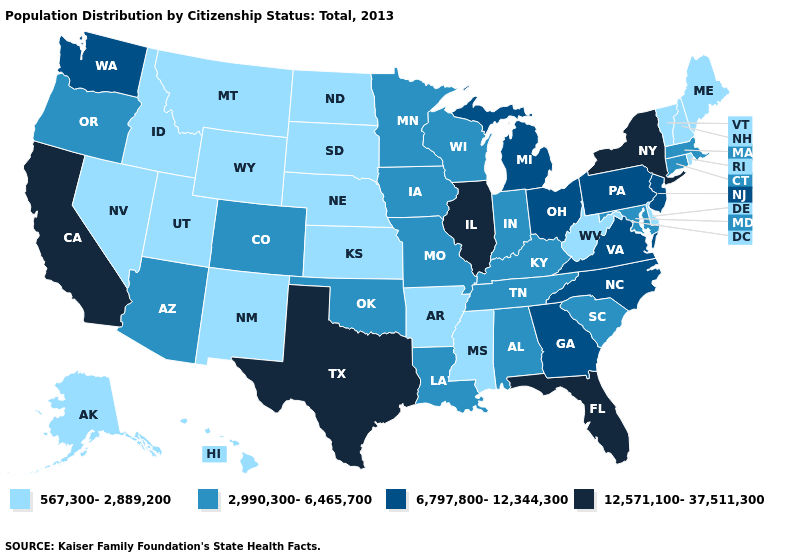Name the states that have a value in the range 2,990,300-6,465,700?
Write a very short answer. Alabama, Arizona, Colorado, Connecticut, Indiana, Iowa, Kentucky, Louisiana, Maryland, Massachusetts, Minnesota, Missouri, Oklahoma, Oregon, South Carolina, Tennessee, Wisconsin. Among the states that border Utah , which have the highest value?
Keep it brief. Arizona, Colorado. Does Pennsylvania have the same value as Kentucky?
Quick response, please. No. Name the states that have a value in the range 12,571,100-37,511,300?
Short answer required. California, Florida, Illinois, New York, Texas. Which states have the lowest value in the USA?
Write a very short answer. Alaska, Arkansas, Delaware, Hawaii, Idaho, Kansas, Maine, Mississippi, Montana, Nebraska, Nevada, New Hampshire, New Mexico, North Dakota, Rhode Island, South Dakota, Utah, Vermont, West Virginia, Wyoming. What is the value of Illinois?
Be succinct. 12,571,100-37,511,300. Which states have the lowest value in the West?
Quick response, please. Alaska, Hawaii, Idaho, Montana, Nevada, New Mexico, Utah, Wyoming. What is the lowest value in states that border Vermont?
Short answer required. 567,300-2,889,200. Name the states that have a value in the range 6,797,800-12,344,300?
Short answer required. Georgia, Michigan, New Jersey, North Carolina, Ohio, Pennsylvania, Virginia, Washington. Name the states that have a value in the range 567,300-2,889,200?
Quick response, please. Alaska, Arkansas, Delaware, Hawaii, Idaho, Kansas, Maine, Mississippi, Montana, Nebraska, Nevada, New Hampshire, New Mexico, North Dakota, Rhode Island, South Dakota, Utah, Vermont, West Virginia, Wyoming. Does Utah have the lowest value in the West?
Answer briefly. Yes. Name the states that have a value in the range 6,797,800-12,344,300?
Write a very short answer. Georgia, Michigan, New Jersey, North Carolina, Ohio, Pennsylvania, Virginia, Washington. What is the lowest value in states that border Florida?
Quick response, please. 2,990,300-6,465,700. What is the value of Illinois?
Keep it brief. 12,571,100-37,511,300. 